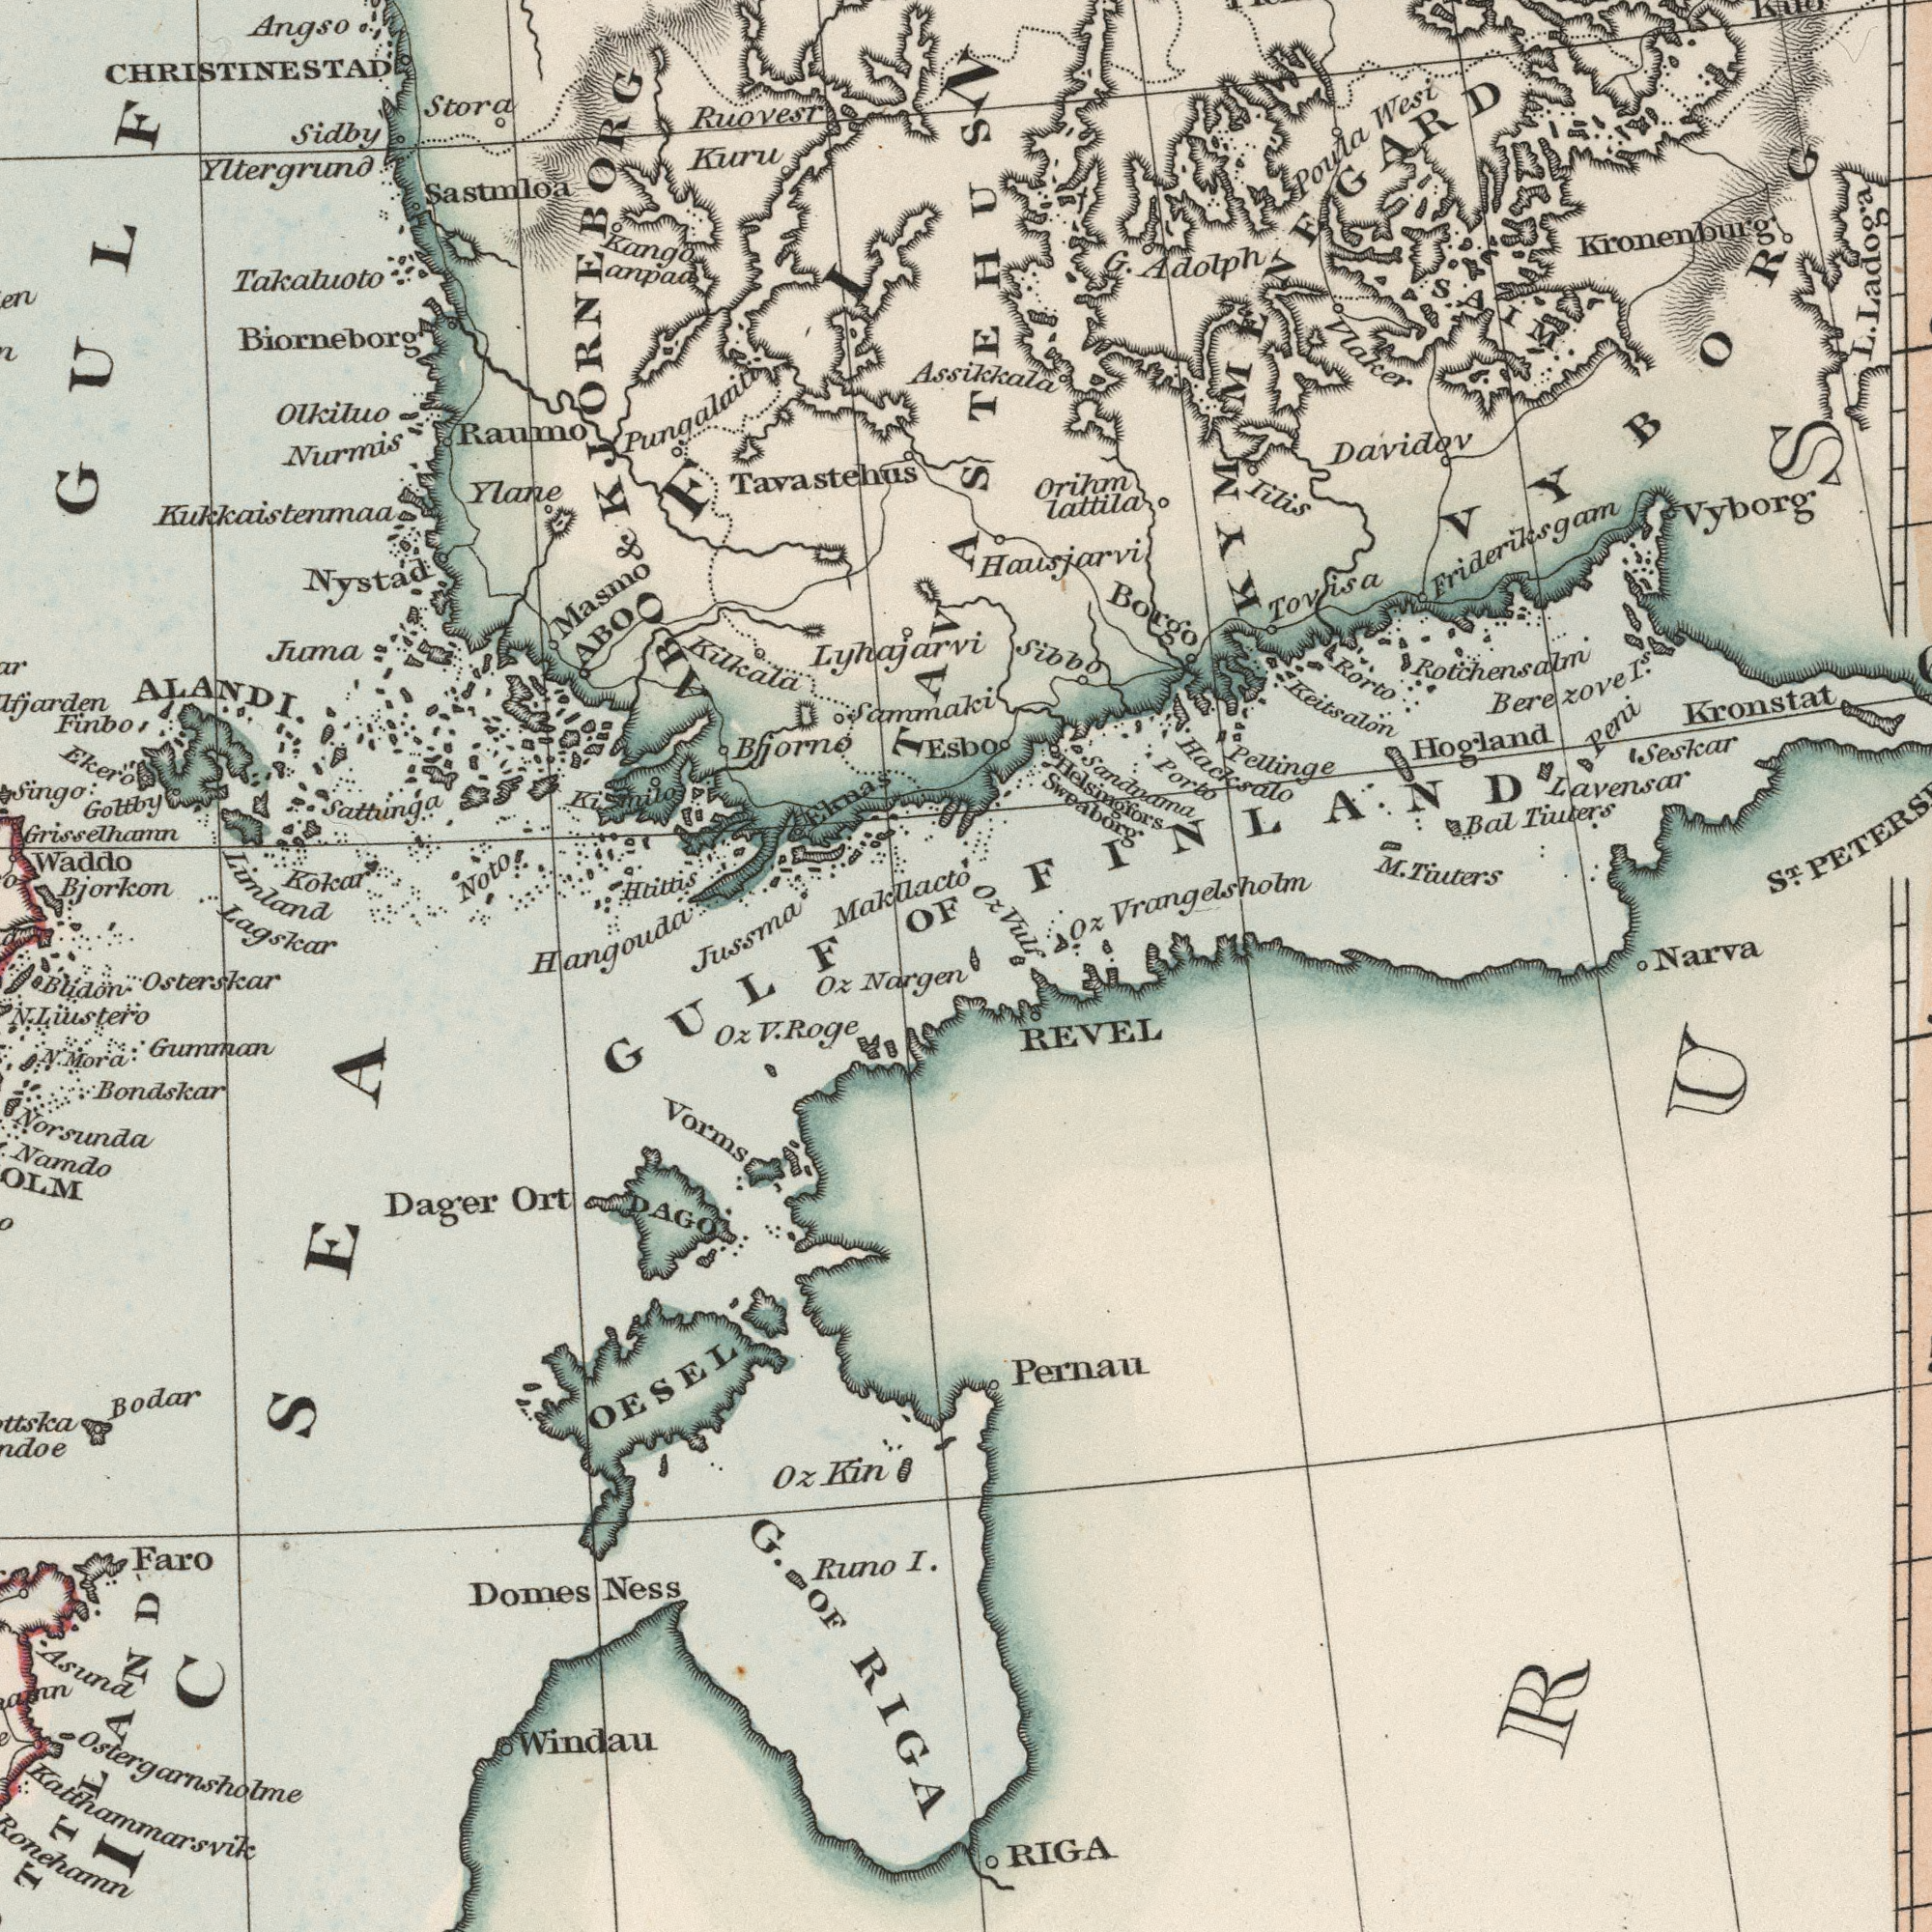What text is shown in the bottom-right quadrant? REVEL RIGA Pernau What text is visible in the upper-left corner? Tavastehus Ruovest Bjorkon Takaluoto Raumo Waddo Kuru Kilkala Olkiluo Masmo Sidby Sattunga ALANDI. Nystad Stora Htittis Bjorno Pungalaiti Sammaki Singo Yltergrund Biorneborg Kokar OF Ekero Lagskar Kango Juma Kukkaistenmaa Noto Ylane Nurmis Lunland Finbo Sastmloa Grisselhamn Makllacto Goltby anpaa Angso Eknas & Lyhajarvi ABO CHRISTINESTAD ABO KJORNEBORG Jussma GULF Hangouda What text appears in the top-right area of the image? Esbo Sweaborg Keitsalon Davidov Hausjarvi Vlaker Sandnama Adolph Narva Tiuters Hogland Wesi Oz Iilis Pellinge Rorto Kronstat Hacksalo Vyborg ST. Borgo Seskar Sibbo Lavensar lattila Tiuters Kronenburg Orihm G. M. KYMMENEGARD L. Assikkala Peni I.<sup>s</sup> Poula Bal Vrangelsholm Tovisa Ladoga Helsingfors Porto Frideriksgam Oz Rotchensalm Berezove SAIM TAVASTEHUS FINLAND VYBORG Vulf What text is visible in the lower-left corner? OESEL Bondskar Liustero Osterskar Dager Norsunda Gumman Bodar Domes Windau Namdo I. Runo Oz Oz Vorms Ort Faro Nargen Ness Ronehamn Budon DAGO RIGA Asund Kin GULF Mora G. V. Oz Ostergarnsholme Katthammarsvik OF ###IC SEA Roge N. N. 